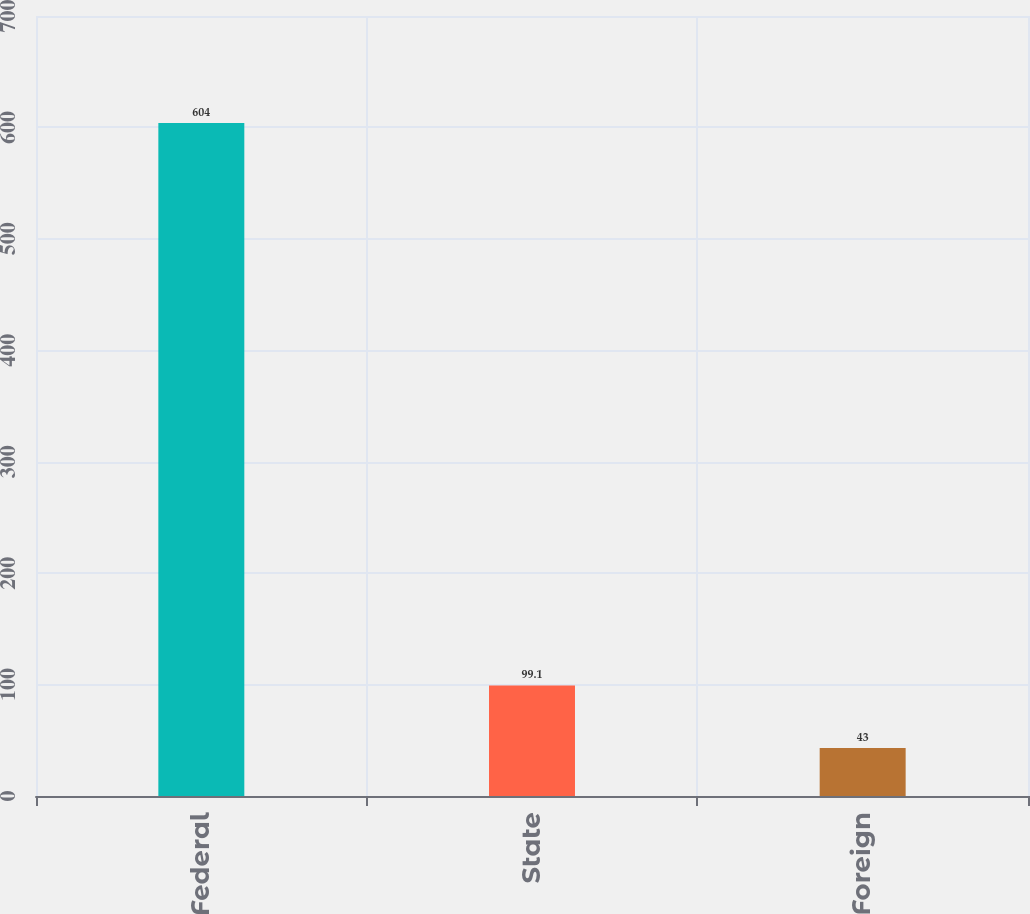Convert chart to OTSL. <chart><loc_0><loc_0><loc_500><loc_500><bar_chart><fcel>Federal<fcel>State<fcel>Foreign<nl><fcel>604<fcel>99.1<fcel>43<nl></chart> 